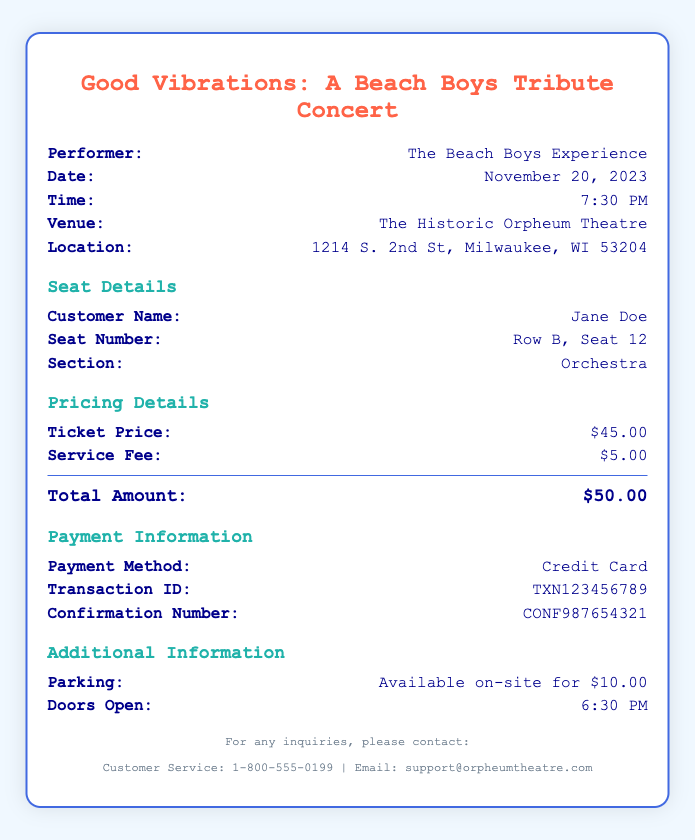What is the date of the concert? The date of the concert is listed under the event details, which is November 20, 2023.
Answer: November 20, 2023 Who is the performer at the concert? The performer is stated in the document as The Beach Boys Experience.
Answer: The Beach Boys Experience What is the seat number? The seat number is provided in the seat details section, which is Row B, Seat 12.
Answer: Row B, Seat 12 How much is the service fee? The service fee is mentioned in the pricing details, which is $5.00.
Answer: $5.00 What time do the doors open? The opening time for the doors is specified in the additional information section, which is 6:30 PM.
Answer: 6:30 PM What is the total amount paid for the ticket? The total amount is calculated based on ticket price and service fee, listed as $50.00.
Answer: $50.00 What is the confirmation number? The confirmation number is provided in the payment information section as CONF987654321.
Answer: CONF987654321 What is the location of the venue? The location is stated in the event details under Venue as 1214 S. 2nd St, Milwaukee, WI 53204.
Answer: 1214 S. 2nd St, Milwaukee, WI 53204 What parking options are available? The parking options are listed in the additional information, available on-site for $10.00.
Answer: Available on-site for $10.00 